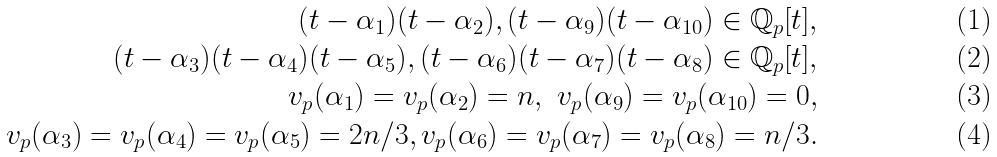Convert formula to latex. <formula><loc_0><loc_0><loc_500><loc_500>( t - \alpha _ { 1 } ) ( t - \alpha _ { 2 } ) , ( t - \alpha _ { 9 } ) ( t - \alpha _ { 1 0 } ) \in \mathbb { Q } _ { p } [ t ] , \\ ( t - \alpha _ { 3 } ) ( t - \alpha _ { 4 } ) ( t - \alpha _ { 5 } ) , ( t - \alpha _ { 6 } ) ( t - \alpha _ { 7 } ) ( t - \alpha _ { 8 } ) \in \mathbb { Q } _ { p } [ t ] , \\ v _ { p } ( \alpha _ { 1 } ) = v _ { p } ( \alpha _ { 2 } ) = n , \ v _ { p } ( \alpha _ { 9 } ) = v _ { p } ( \alpha _ { 1 0 } ) = 0 , \\ v _ { p } ( \alpha _ { 3 } ) = v _ { p } ( \alpha _ { 4 } ) = v _ { p } ( \alpha _ { 5 } ) = 2 n / 3 , v _ { p } ( \alpha _ { 6 } ) = v _ { p } ( \alpha _ { 7 } ) = v _ { p } ( \alpha _ { 8 } ) = n / 3 .</formula> 